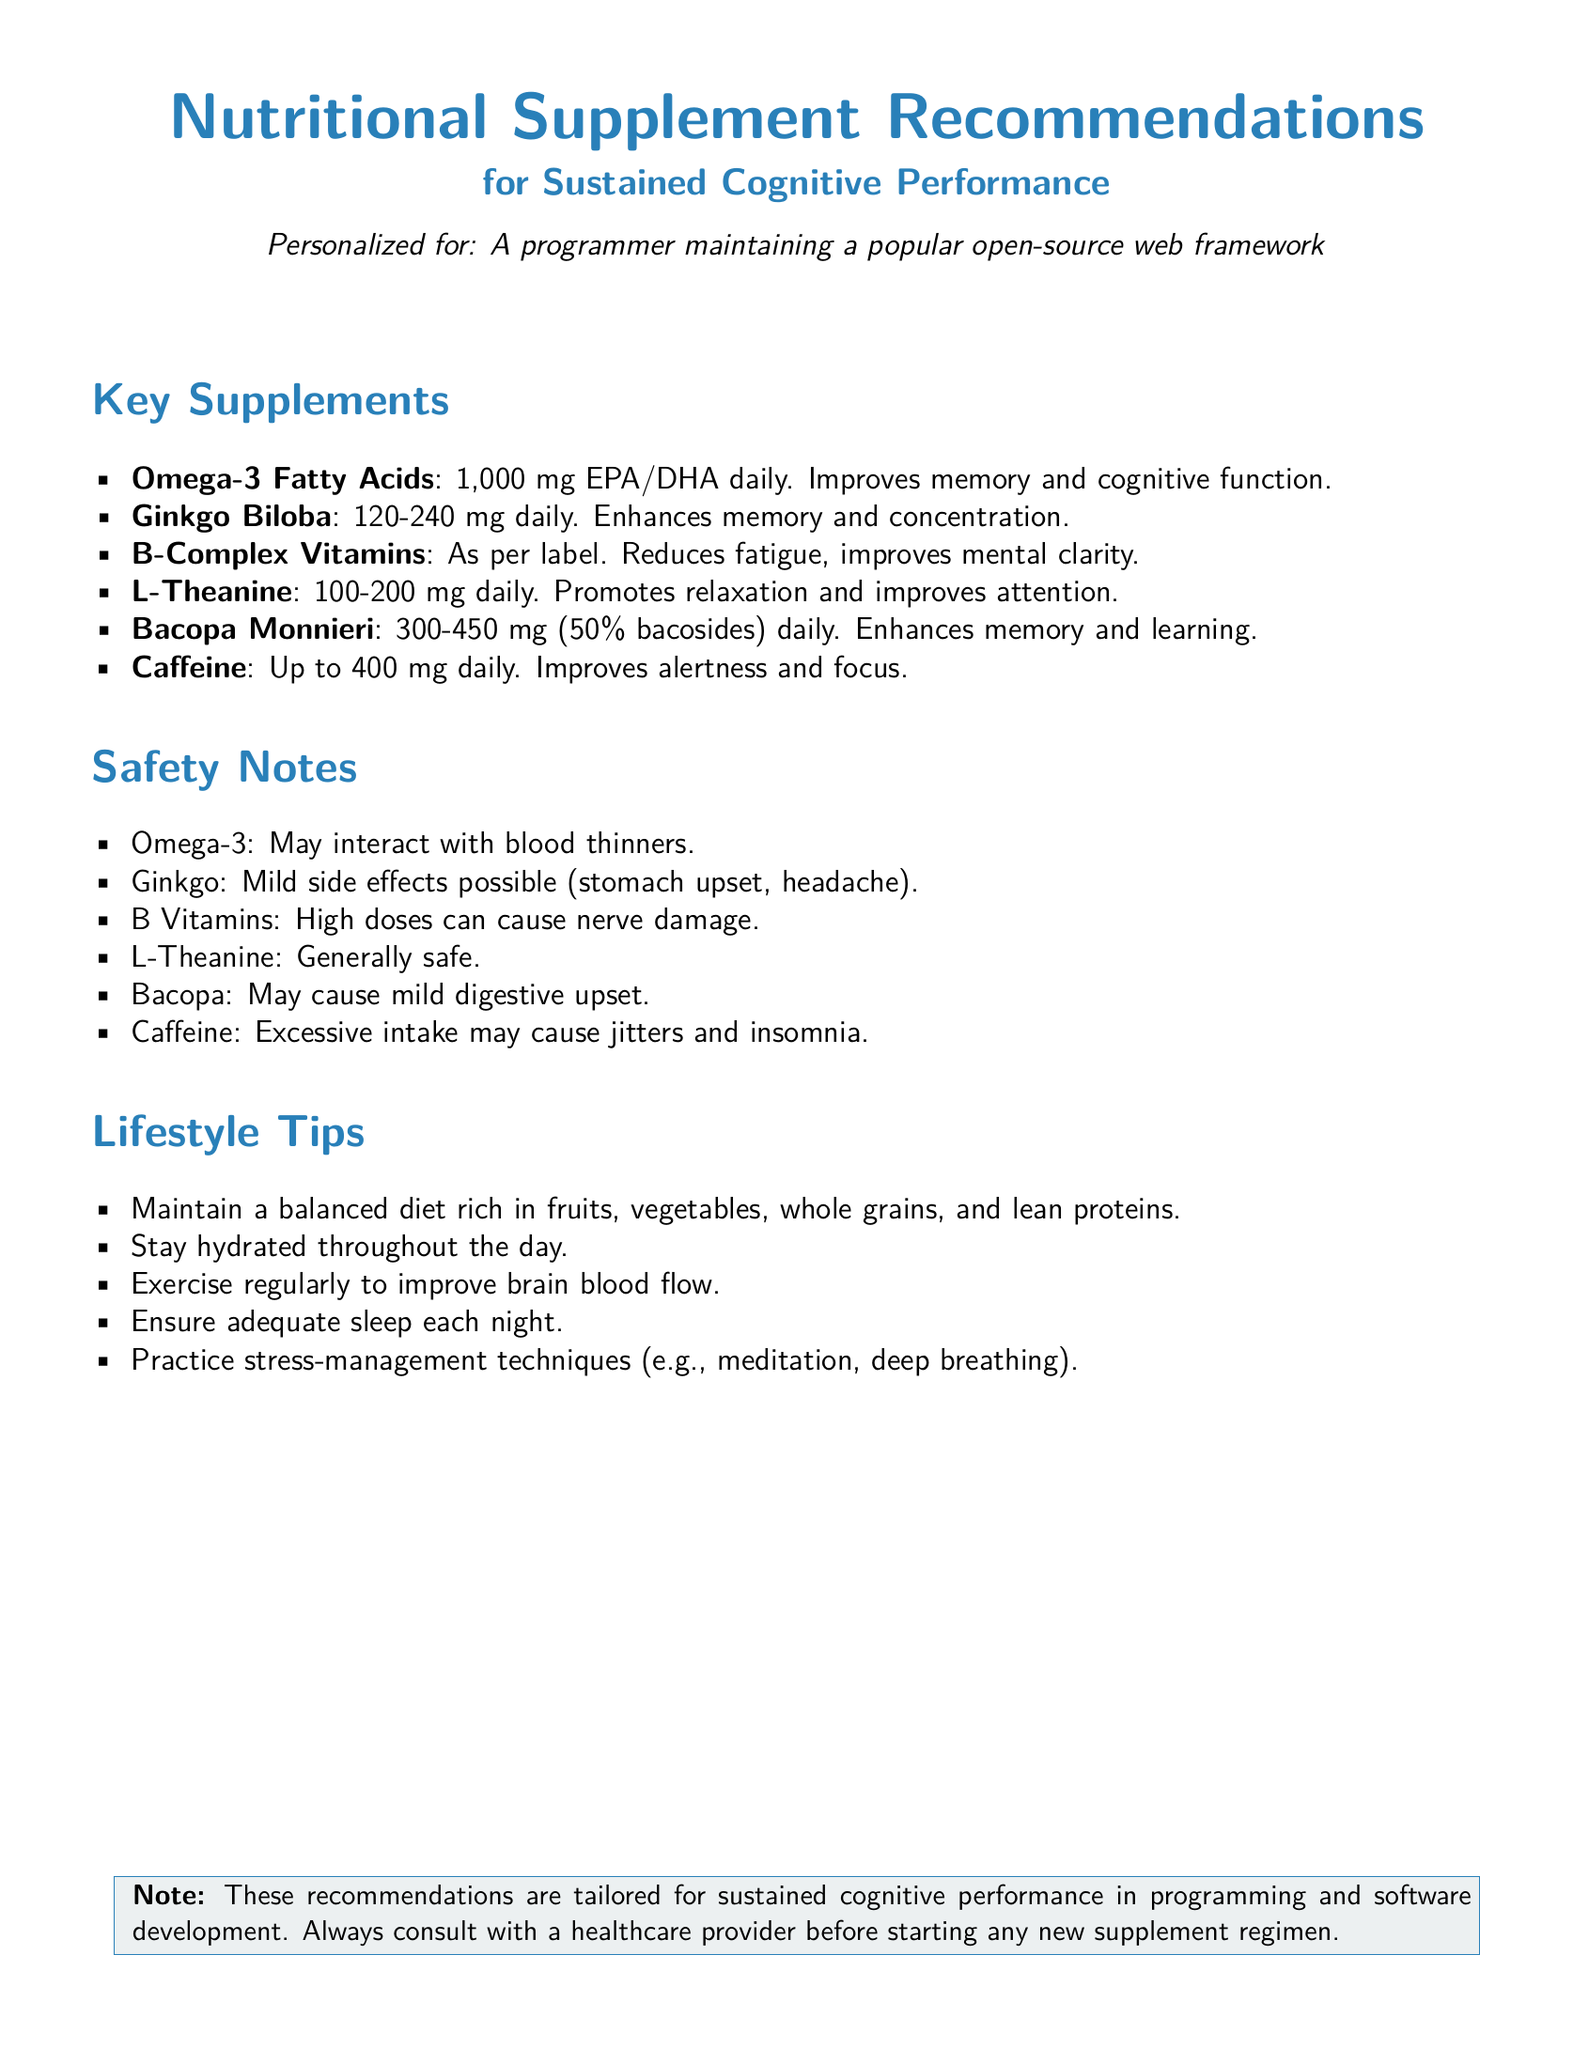What is the primary focus of the document? The document recommends nutritional supplements for cognitive performance.
Answer: Nutritional Supplement Recommendations for Sustained Cognitive Performance What dosage of Omega-3 Fatty Acids is recommended? The document specifies the daily recommended dosage of Omega-3 Fatty Acids.
Answer: 1,000 mg EPA/DHA What is the safety note associated with Omega-3? The document provides a safety note about Omega-3 and its potential interactions.
Answer: May interact with blood thinners How much L-Theanine should one take daily? The document mentions the daily dosage range for L-Theanine.
Answer: 100-200 mg What supplement is suggested to enhance memory and learning? The document highlights a specific supplement known for enhancing memory and learning.
Answer: Bacopa Monnieri What is a lifestyle tip mentioned in the document? The document includes various tips, and one is specifically mentioned for overall enhancement.
Answer: Maintain a balanced diet How many mg of caffeine is recommended per day? The document outlines a maximum recommended daily dosage for caffeine.
Answer: Up to 400 mg What might excessive caffeine intake cause? The document specifies a potential effect of consuming too much caffeine.
Answer: Jitters and insomnia 